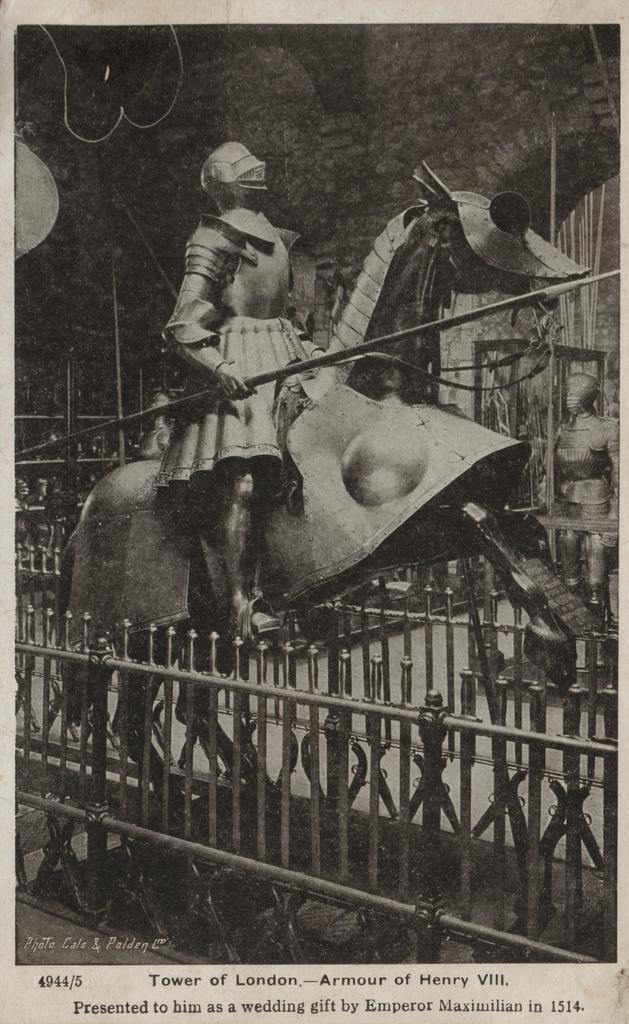What is the color scheme of the image? The image is black and white. What can be seen in the image besides the color scheme? There are statues in the image, and there is a fence around the statues. What is visible in the background of the image? There is a wall visible in the background of the image. Is there any text in the image? Yes, there is some text at the bottom of the image. Can you tell me how many umbrellas are being sold in the store in the image? There is no store or umbrella present in the image; it features statues, a fence, and a wall. What type of hairstyle does the statue have in the image? The statues in the image do not have hair, as they are inanimate objects. 